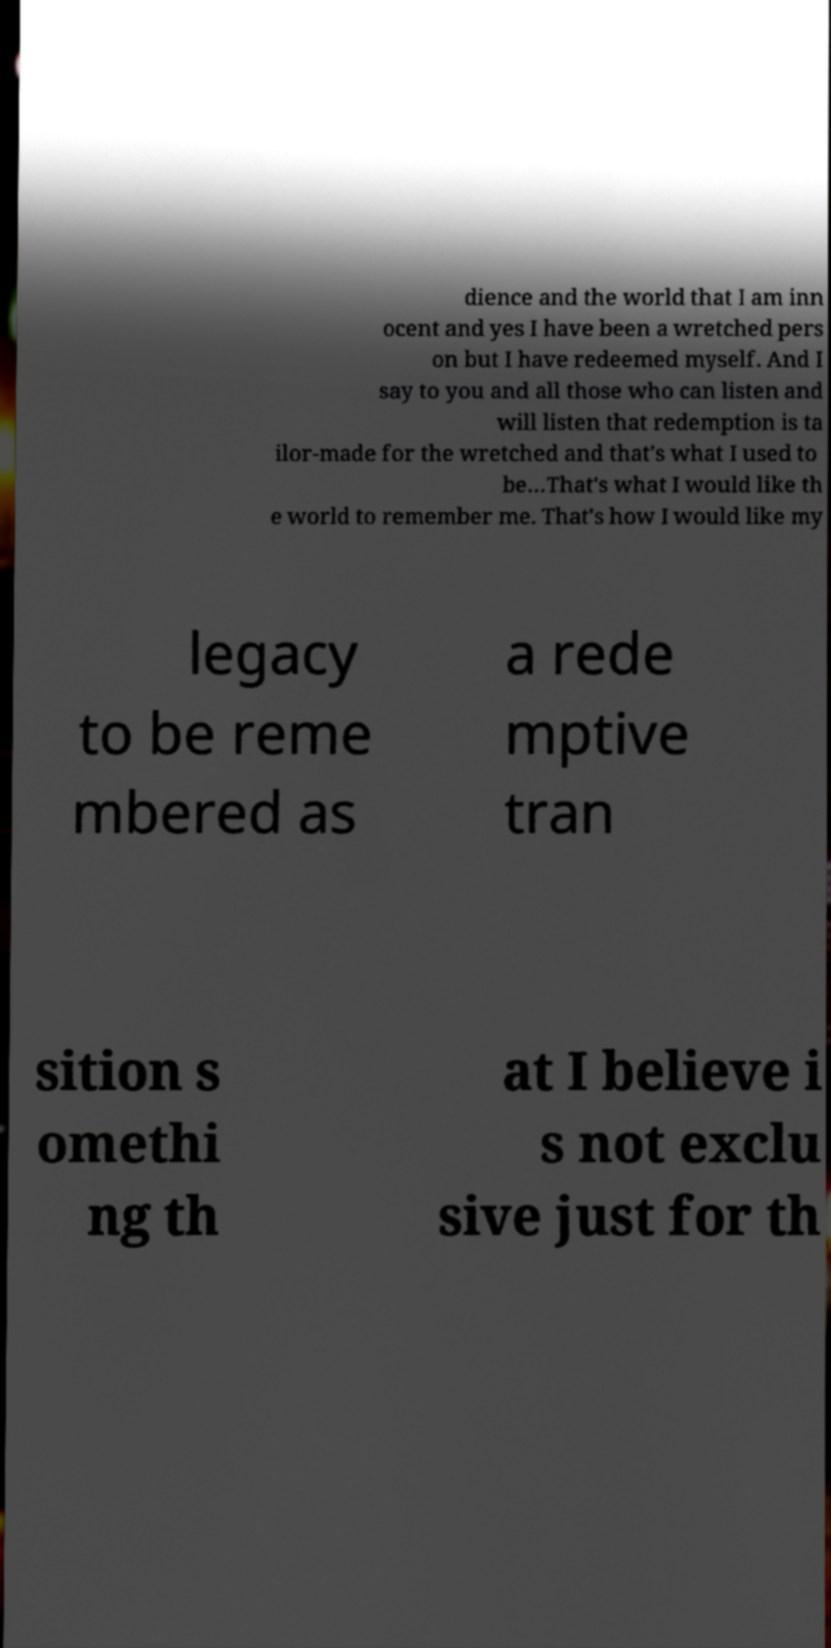For documentation purposes, I need the text within this image transcribed. Could you provide that? dience and the world that I am inn ocent and yes I have been a wretched pers on but I have redeemed myself. And I say to you and all those who can listen and will listen that redemption is ta ilor-made for the wretched and that's what I used to be…That's what I would like th e world to remember me. That's how I would like my legacy to be reme mbered as a rede mptive tran sition s omethi ng th at I believe i s not exclu sive just for th 